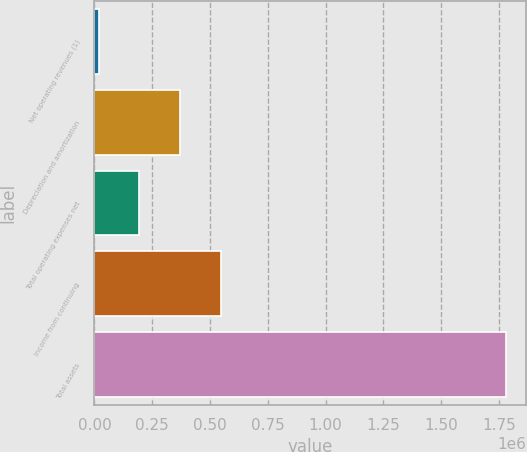Convert chart. <chart><loc_0><loc_0><loc_500><loc_500><bar_chart><fcel>Net operating revenues (1)<fcel>Depreciation and amortization<fcel>Total operating expenses net<fcel>Income from continuing<fcel>Total assets<nl><fcel>17874<fcel>369872<fcel>193873<fcel>545871<fcel>1.77786e+06<nl></chart> 